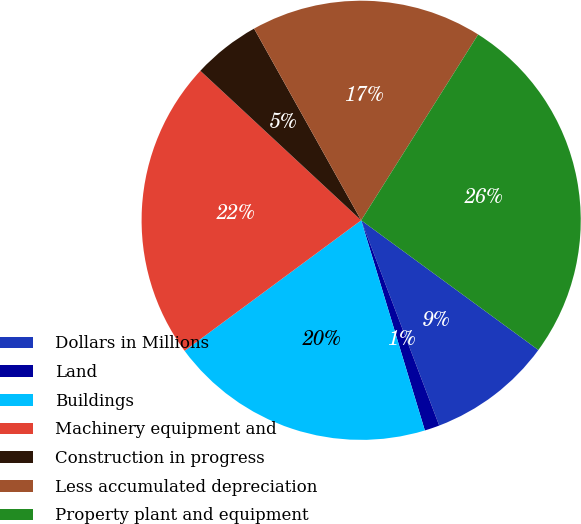Convert chart. <chart><loc_0><loc_0><loc_500><loc_500><pie_chart><fcel>Dollars in Millions<fcel>Land<fcel>Buildings<fcel>Machinery equipment and<fcel>Construction in progress<fcel>Less accumulated depreciation<fcel>Property plant and equipment<nl><fcel>9.16%<fcel>1.1%<fcel>19.55%<fcel>22.05%<fcel>4.97%<fcel>17.05%<fcel>26.11%<nl></chart> 